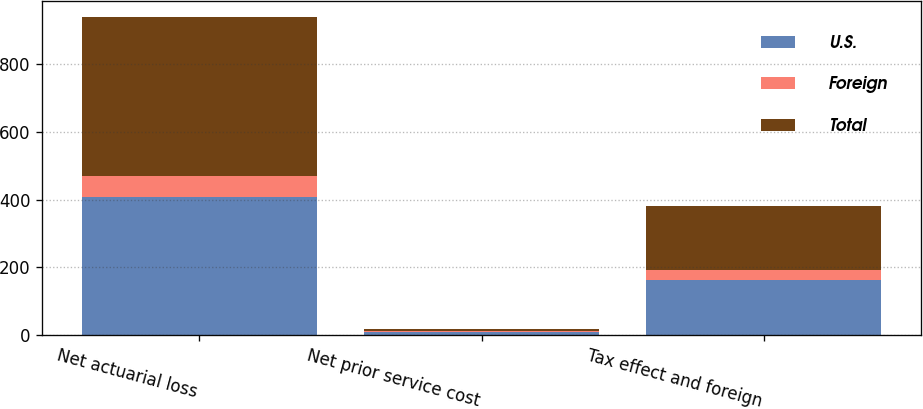<chart> <loc_0><loc_0><loc_500><loc_500><stacked_bar_chart><ecel><fcel>Net actuarial loss<fcel>Net prior service cost<fcel>Tax effect and foreign<nl><fcel>U.S.<fcel>406.7<fcel>9.7<fcel>163.3<nl><fcel>Foreign<fcel>62.4<fcel>3.6<fcel>27.9<nl><fcel>Total<fcel>469.1<fcel>6.1<fcel>191.2<nl></chart> 